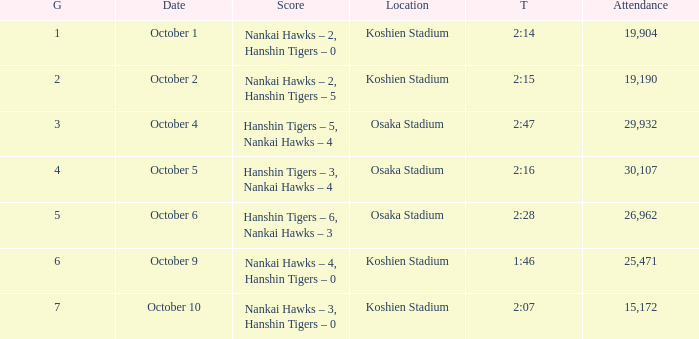Which score corresponds to a time of 2 minutes and 28 seconds? Hanshin Tigers – 6, Nankai Hawks – 3. 